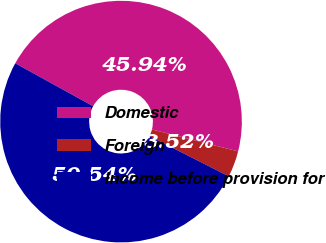Convert chart to OTSL. <chart><loc_0><loc_0><loc_500><loc_500><pie_chart><fcel>Domestic<fcel>Foreign<fcel>Income before provision for<nl><fcel>45.94%<fcel>3.52%<fcel>50.53%<nl></chart> 